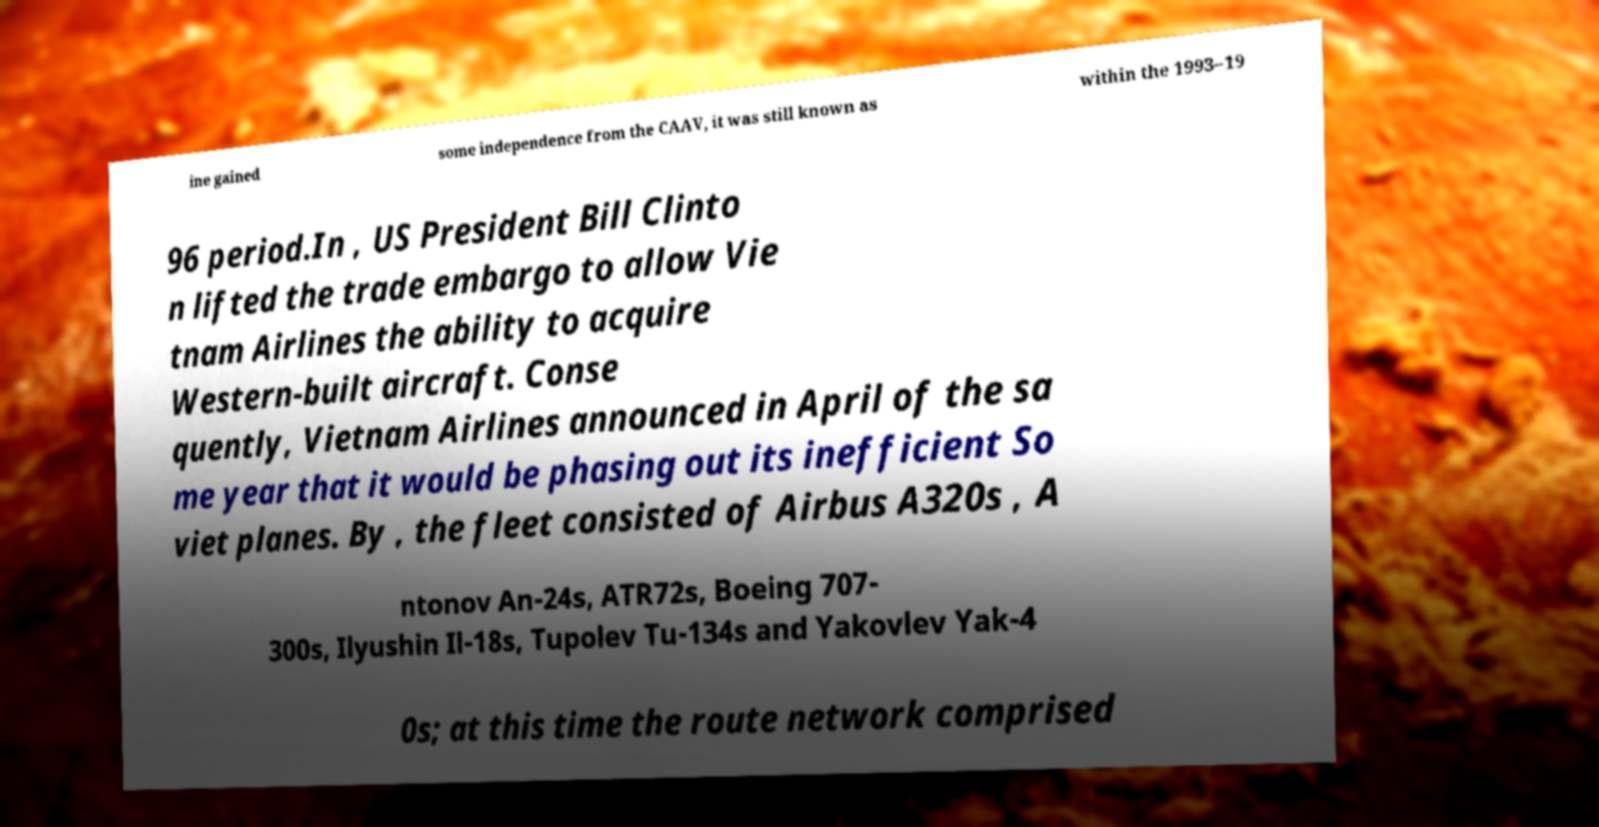Could you assist in decoding the text presented in this image and type it out clearly? ine gained some independence from the CAAV, it was still known as within the 1993–19 96 period.In , US President Bill Clinto n lifted the trade embargo to allow Vie tnam Airlines the ability to acquire Western-built aircraft. Conse quently, Vietnam Airlines announced in April of the sa me year that it would be phasing out its inefficient So viet planes. By , the fleet consisted of Airbus A320s , A ntonov An-24s, ATR72s, Boeing 707- 300s, Ilyushin Il-18s, Tupolev Tu-134s and Yakovlev Yak-4 0s; at this time the route network comprised 